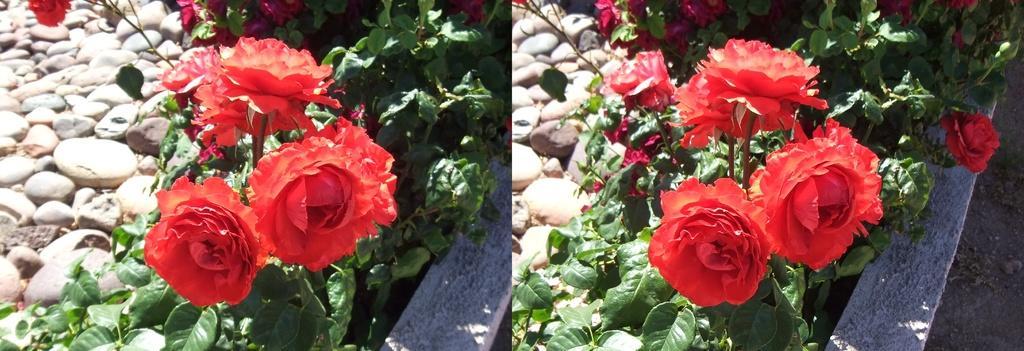In one or two sentences, can you explain what this image depicts? In the picture we can see two images in it, we can see a plant with roses, flowers which are red in color and beside the plant we can see some stones. 